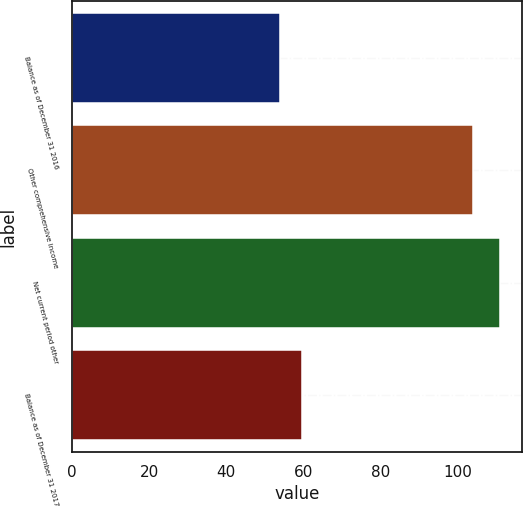<chart> <loc_0><loc_0><loc_500><loc_500><bar_chart><fcel>Balance as of December 31 2016<fcel>Other comprehensive income<fcel>Net current period other<fcel>Balance as of December 31 2017<nl><fcel>54<fcel>104<fcel>111<fcel>59.7<nl></chart> 